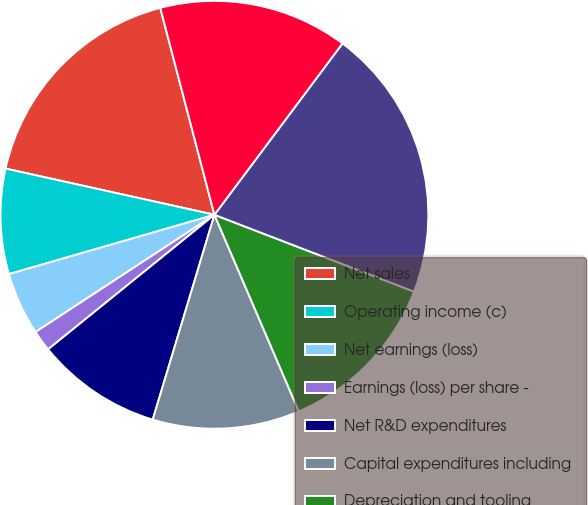Convert chart to OTSL. <chart><loc_0><loc_0><loc_500><loc_500><pie_chart><fcel>Net sales<fcel>Operating income (c)<fcel>Net earnings (loss)<fcel>Earnings (loss) per share -<fcel>Net R&D expenditures<fcel>Capital expenditures including<fcel>Depreciation and tooling<fcel>Number of employees<fcel>Cash<nl><fcel>17.46%<fcel>7.94%<fcel>4.76%<fcel>1.59%<fcel>9.52%<fcel>11.11%<fcel>12.7%<fcel>20.63%<fcel>14.29%<nl></chart> 